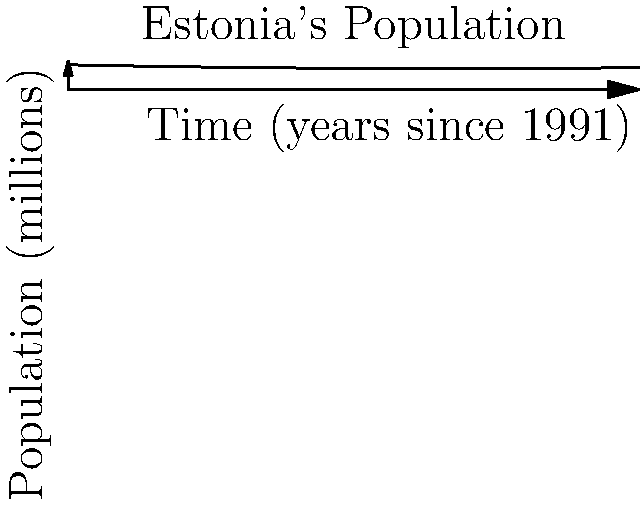As an Estonian political scientist, you're analyzing the population growth of Estonia since its independence in 1991. The graph shows Estonia's population curve from 1991 to 2021. At which point in time, measured in years since 1991, was the rate of population change equal to zero? Explain your reasoning using calculus concepts. To find when the rate of population change was zero, we need to follow these steps:

1) The curve represents the population function $P(t)$, where $t$ is time in years since 1991.

2) The rate of change of population is given by the derivative $P'(t)$.

3) We want to find when $P'(t) = 0$.

4) From the graph, we can see that the population curve has a minimum point. At this point, the rate of change (slope of the tangent line) is zero.

5) To find this point exactly, we need the function for the curve. Based on the shape, it appears to be a quadratic function of the form:

   $P(t) = a + bt + ct^2$

   where $a$, $b$, and $c$ are constants.

6) The derivative of this function is:

   $P'(t) = b + 2ct$

7) Setting this equal to zero:

   $0 = b + 2ct$

8) Solving for $t$:

   $t = -\frac{b}{2c}$

9) From the graph, this occurs at approximately 20 years after 1991, or around 2011.

This point represents when Estonia's population was at its lowest and began to increase again.
Answer: 20 years after 1991 (approximately 2011) 